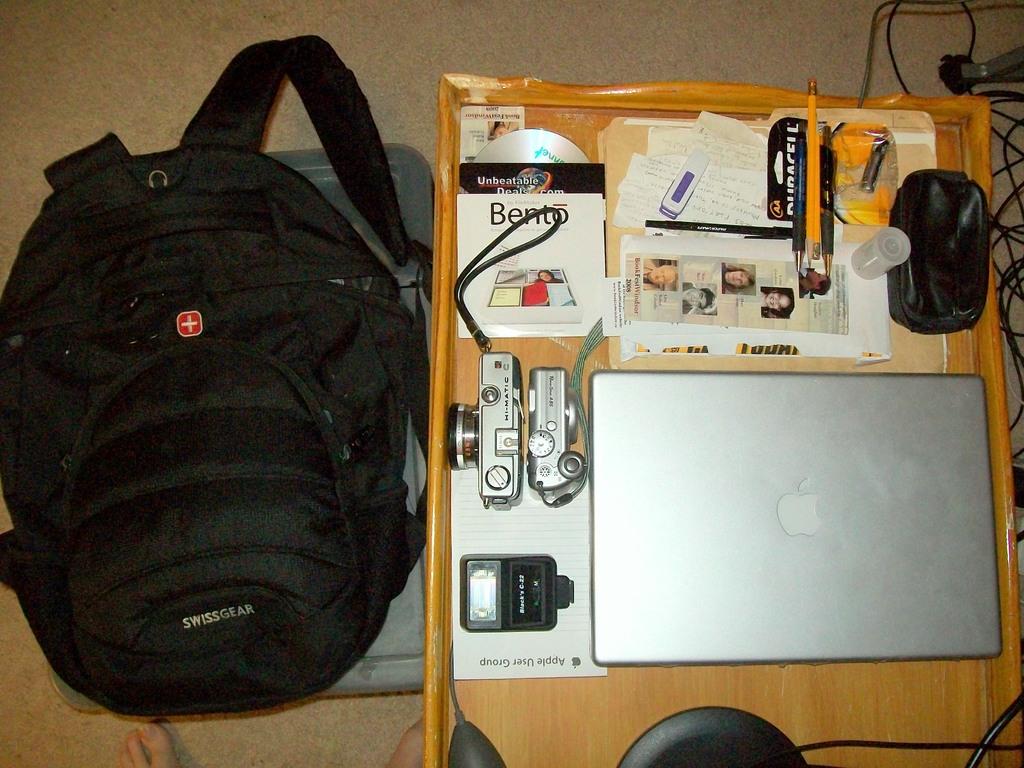What brand of backpack is this?
Your answer should be compact. Swissgear. 